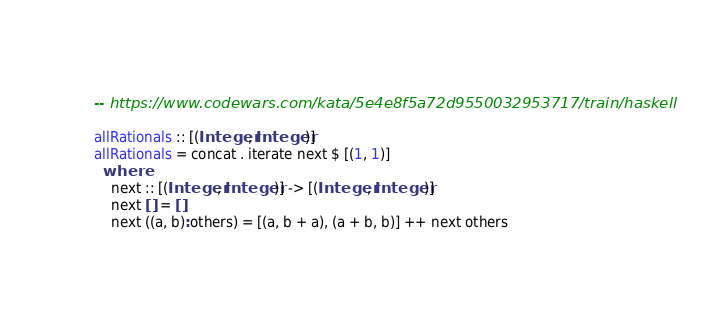Convert code to text. <code><loc_0><loc_0><loc_500><loc_500><_Haskell_>
-- https://www.codewars.com/kata/5e4e8f5a72d9550032953717/train/haskell

allRationals :: [(Integer, Integer)]
allRationals = concat . iterate next $ [(1, 1)]
  where
    next :: [(Integer, Integer)] -> [(Integer, Integer)]
    next [] = []
    next ((a, b):others) = [(a, b + a), (a + b, b)] ++ next others
</code> 